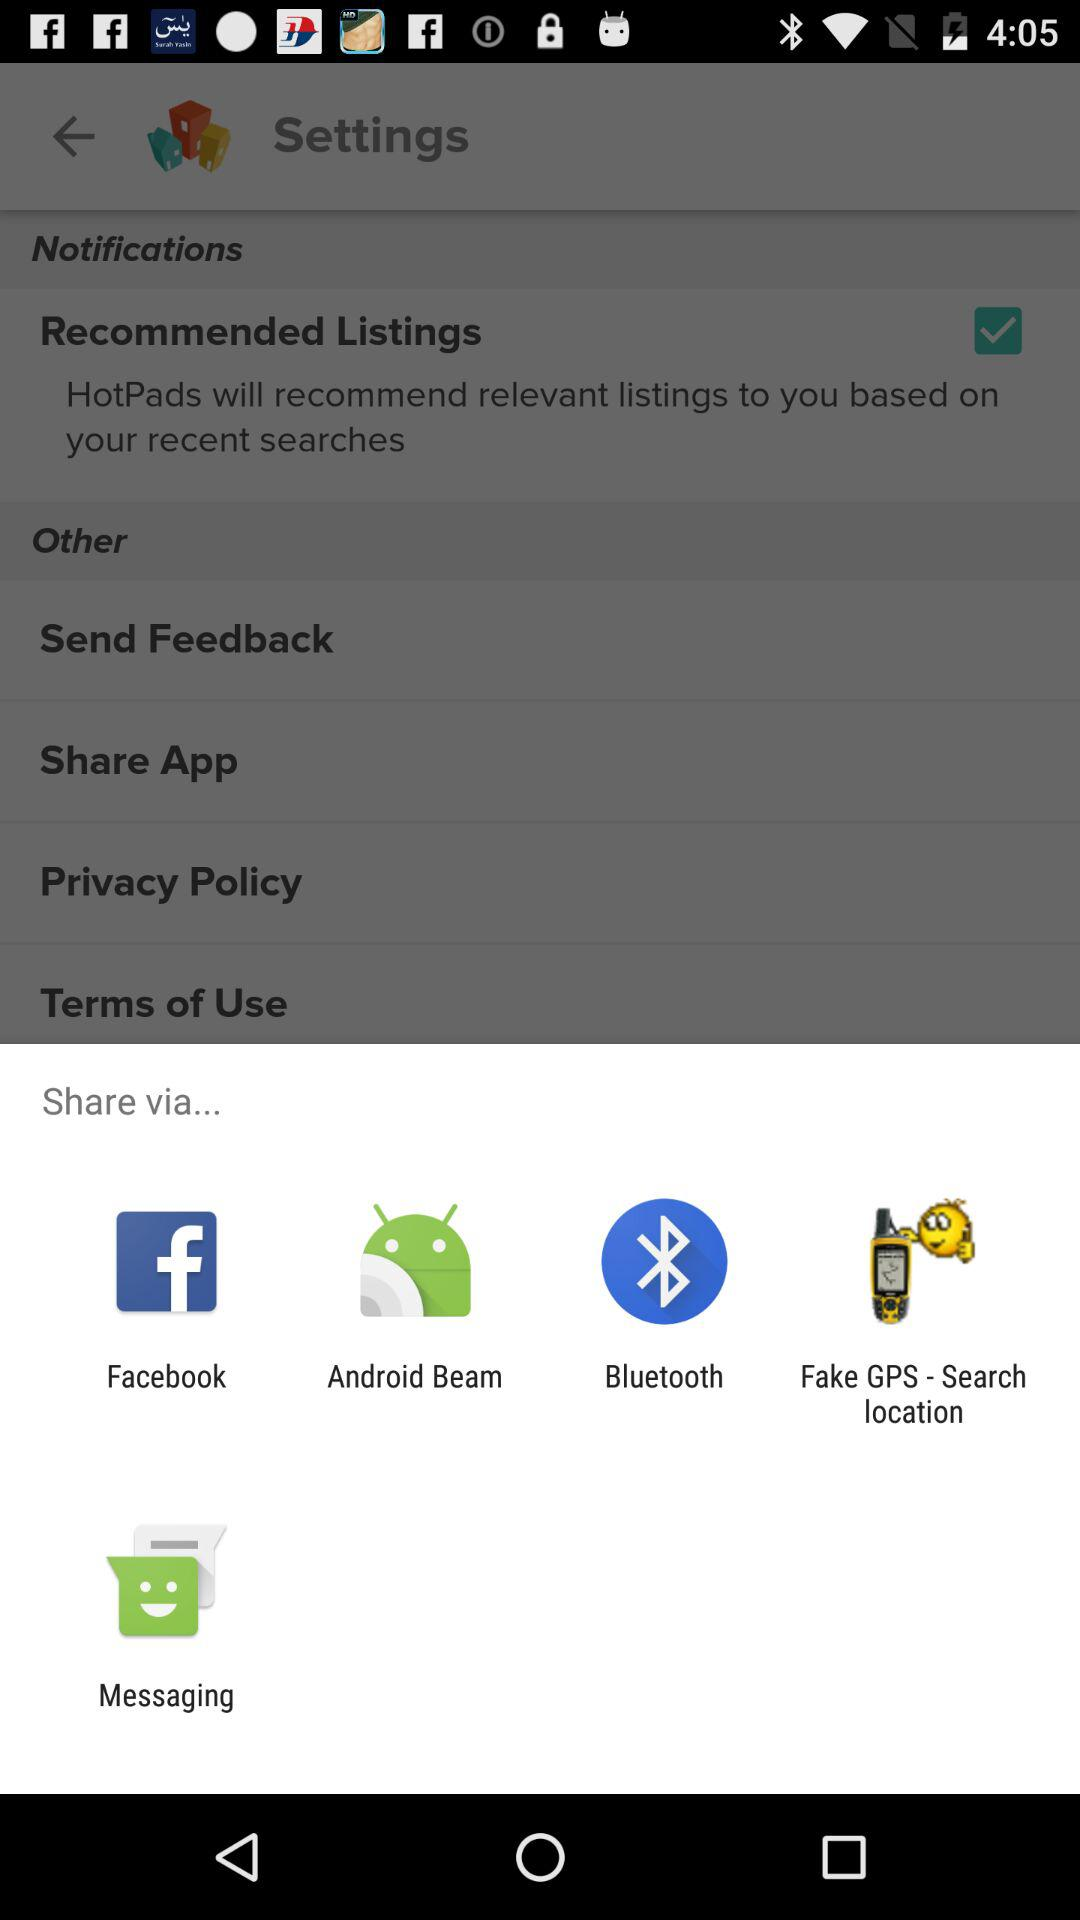What are the applications that may be used to share content? You can share it with Facebook, Android Beam, Bluetooth, Fake GPS - Search location and Messaging. 